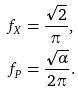<formula> <loc_0><loc_0><loc_500><loc_500>f _ { X } & = \frac { \sqrt { 2 } } { \pi } , \\ f _ { P } & = \frac { \sqrt { \alpha } } { 2 \pi } .</formula> 